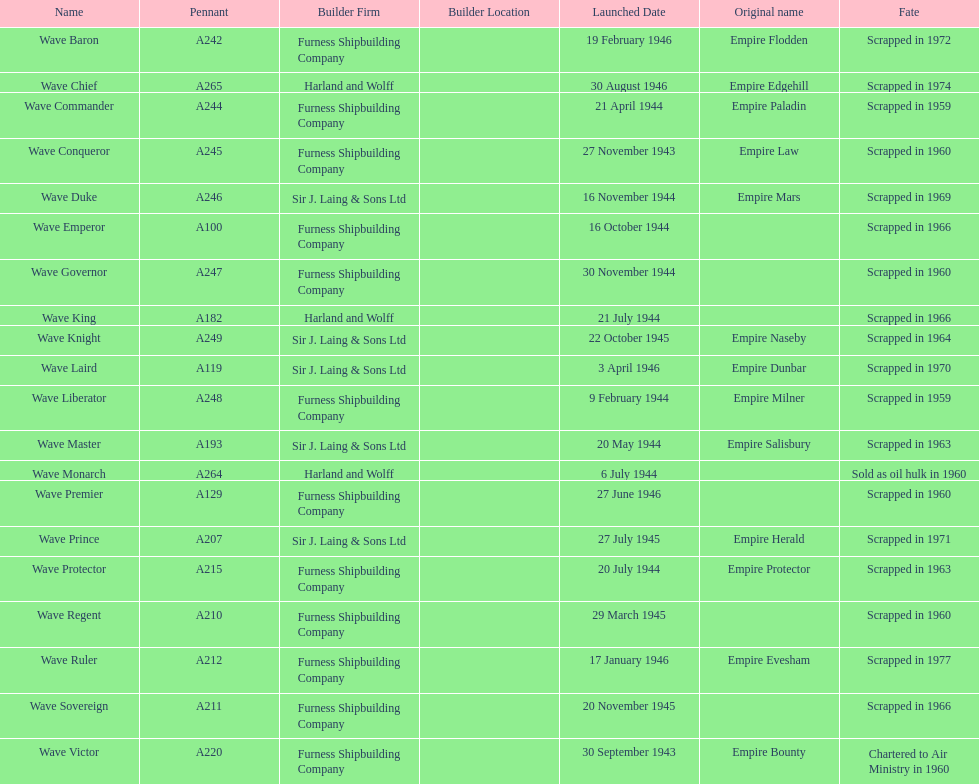Name a builder with "and" in the name. Harland and Wolff. 